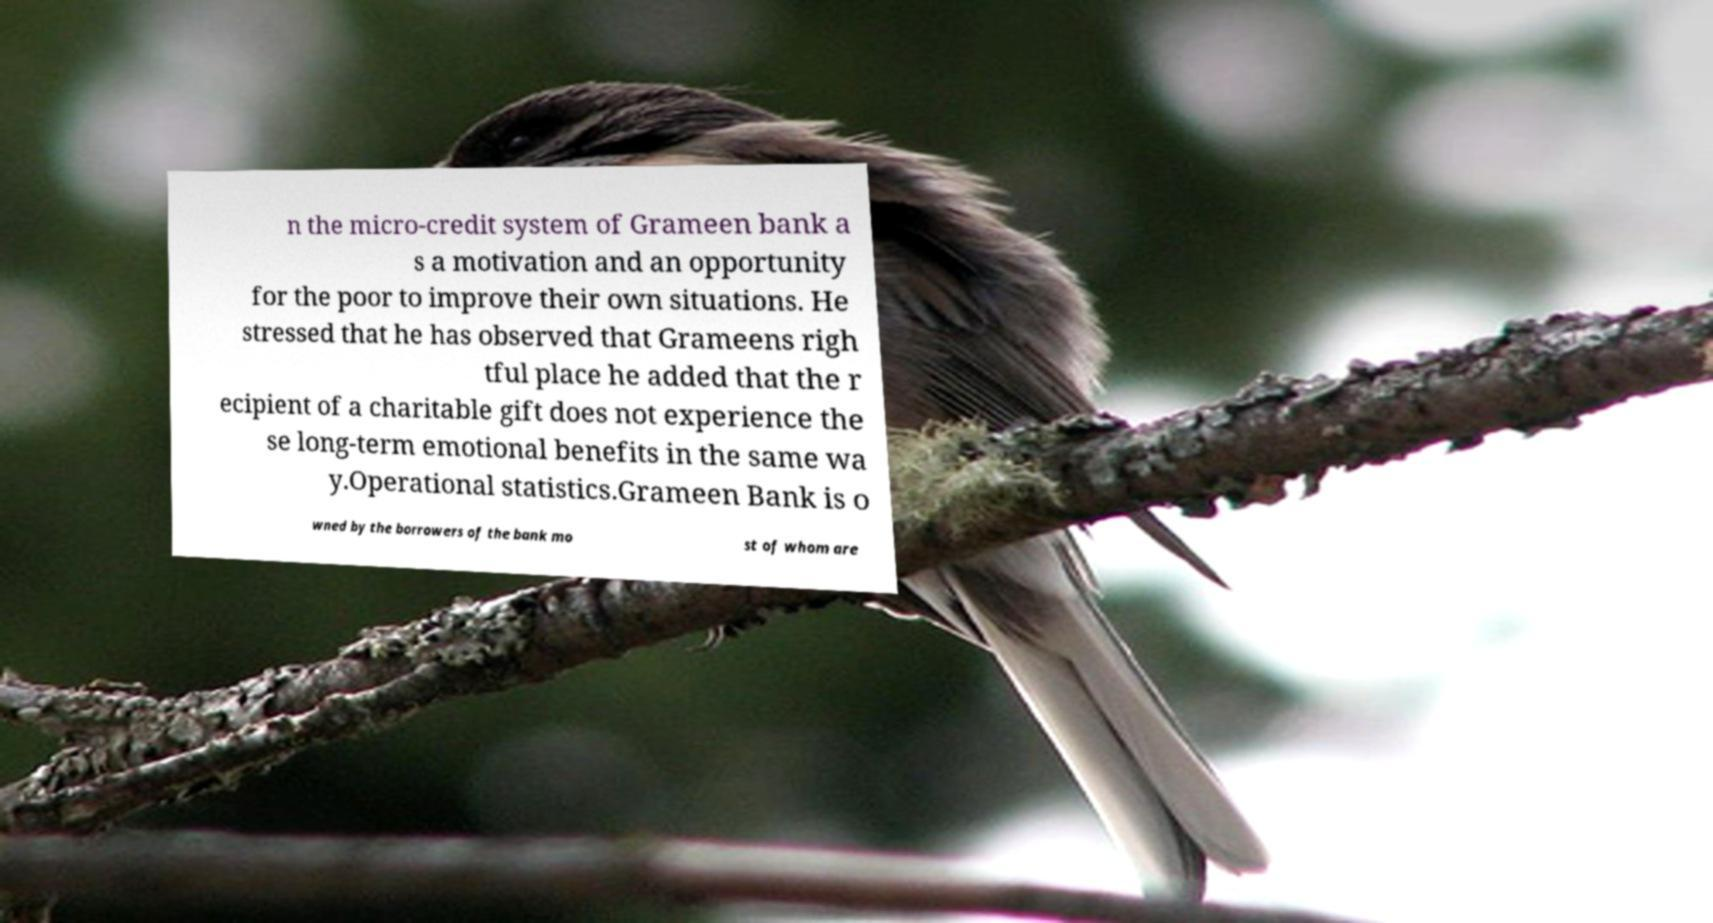For documentation purposes, I need the text within this image transcribed. Could you provide that? n the micro-credit system of Grameen bank a s a motivation and an opportunity for the poor to improve their own situations. He stressed that he has observed that Grameens righ tful place he added that the r ecipient of a charitable gift does not experience the se long-term emotional benefits in the same wa y.Operational statistics.Grameen Bank is o wned by the borrowers of the bank mo st of whom are 